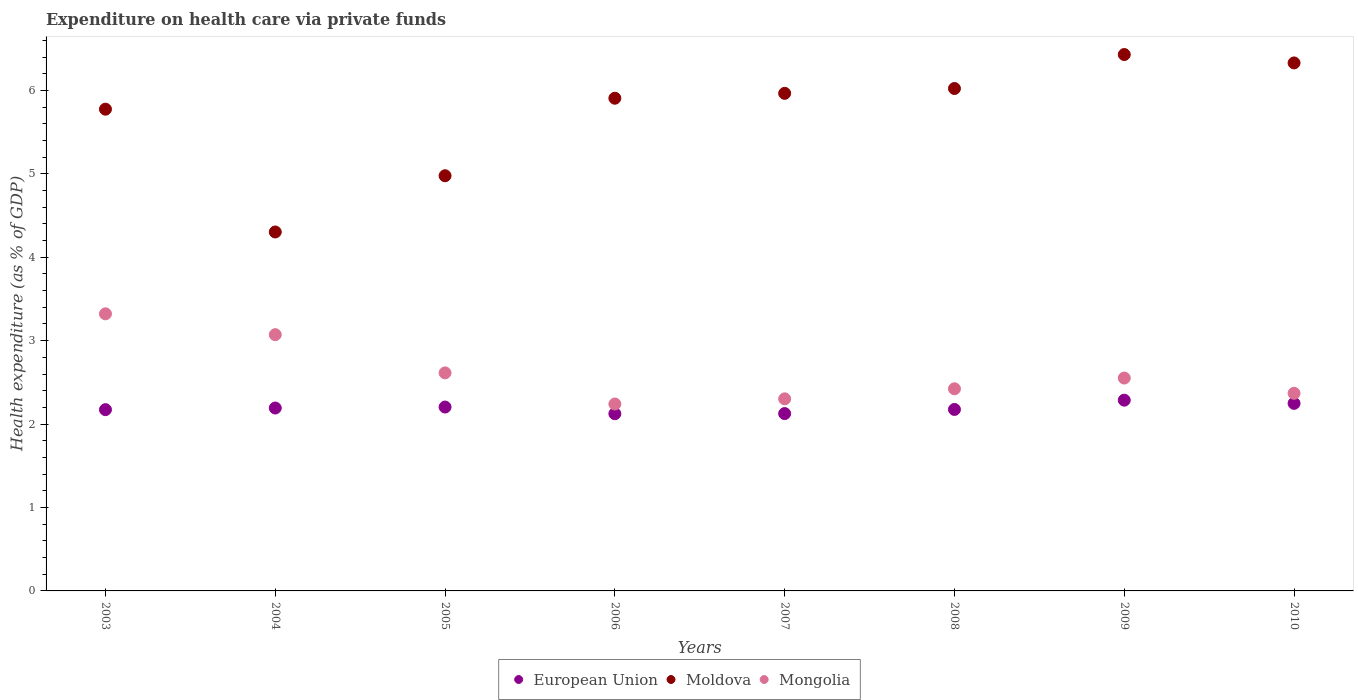What is the expenditure made on health care in Mongolia in 2004?
Offer a very short reply. 3.07. Across all years, what is the maximum expenditure made on health care in European Union?
Your answer should be very brief. 2.29. Across all years, what is the minimum expenditure made on health care in Moldova?
Your response must be concise. 4.3. In which year was the expenditure made on health care in Mongolia minimum?
Ensure brevity in your answer.  2006. What is the total expenditure made on health care in Mongolia in the graph?
Give a very brief answer. 20.9. What is the difference between the expenditure made on health care in Moldova in 2008 and that in 2009?
Keep it short and to the point. -0.41. What is the difference between the expenditure made on health care in Moldova in 2008 and the expenditure made on health care in Mongolia in 2007?
Your response must be concise. 3.72. What is the average expenditure made on health care in European Union per year?
Keep it short and to the point. 2.19. In the year 2007, what is the difference between the expenditure made on health care in Mongolia and expenditure made on health care in Moldova?
Offer a very short reply. -3.66. In how many years, is the expenditure made on health care in European Union greater than 4.6 %?
Provide a succinct answer. 0. What is the ratio of the expenditure made on health care in Mongolia in 2006 to that in 2010?
Give a very brief answer. 0.95. Is the expenditure made on health care in Mongolia in 2003 less than that in 2007?
Provide a succinct answer. No. Is the difference between the expenditure made on health care in Mongolia in 2005 and 2007 greater than the difference between the expenditure made on health care in Moldova in 2005 and 2007?
Your answer should be compact. Yes. What is the difference between the highest and the second highest expenditure made on health care in Moldova?
Give a very brief answer. 0.1. What is the difference between the highest and the lowest expenditure made on health care in European Union?
Offer a very short reply. 0.16. In how many years, is the expenditure made on health care in European Union greater than the average expenditure made on health care in European Union taken over all years?
Offer a very short reply. 4. Is the expenditure made on health care in Moldova strictly less than the expenditure made on health care in Mongolia over the years?
Your response must be concise. No. How many years are there in the graph?
Make the answer very short. 8. Are the values on the major ticks of Y-axis written in scientific E-notation?
Make the answer very short. No. What is the title of the graph?
Offer a terse response. Expenditure on health care via private funds. What is the label or title of the X-axis?
Your response must be concise. Years. What is the label or title of the Y-axis?
Your answer should be very brief. Health expenditure (as % of GDP). What is the Health expenditure (as % of GDP) of European Union in 2003?
Offer a very short reply. 2.17. What is the Health expenditure (as % of GDP) of Moldova in 2003?
Make the answer very short. 5.78. What is the Health expenditure (as % of GDP) in Mongolia in 2003?
Provide a succinct answer. 3.32. What is the Health expenditure (as % of GDP) in European Union in 2004?
Ensure brevity in your answer.  2.19. What is the Health expenditure (as % of GDP) in Moldova in 2004?
Make the answer very short. 4.3. What is the Health expenditure (as % of GDP) of Mongolia in 2004?
Make the answer very short. 3.07. What is the Health expenditure (as % of GDP) of European Union in 2005?
Keep it short and to the point. 2.2. What is the Health expenditure (as % of GDP) in Moldova in 2005?
Ensure brevity in your answer.  4.98. What is the Health expenditure (as % of GDP) of Mongolia in 2005?
Ensure brevity in your answer.  2.61. What is the Health expenditure (as % of GDP) in European Union in 2006?
Provide a short and direct response. 2.12. What is the Health expenditure (as % of GDP) of Moldova in 2006?
Your answer should be compact. 5.91. What is the Health expenditure (as % of GDP) of Mongolia in 2006?
Offer a very short reply. 2.24. What is the Health expenditure (as % of GDP) in European Union in 2007?
Make the answer very short. 2.13. What is the Health expenditure (as % of GDP) of Moldova in 2007?
Provide a short and direct response. 5.96. What is the Health expenditure (as % of GDP) of Mongolia in 2007?
Offer a terse response. 2.3. What is the Health expenditure (as % of GDP) of European Union in 2008?
Your answer should be very brief. 2.18. What is the Health expenditure (as % of GDP) in Moldova in 2008?
Keep it short and to the point. 6.02. What is the Health expenditure (as % of GDP) in Mongolia in 2008?
Ensure brevity in your answer.  2.42. What is the Health expenditure (as % of GDP) of European Union in 2009?
Keep it short and to the point. 2.29. What is the Health expenditure (as % of GDP) of Moldova in 2009?
Give a very brief answer. 6.43. What is the Health expenditure (as % of GDP) of Mongolia in 2009?
Your response must be concise. 2.55. What is the Health expenditure (as % of GDP) of European Union in 2010?
Offer a terse response. 2.25. What is the Health expenditure (as % of GDP) of Moldova in 2010?
Offer a very short reply. 6.33. What is the Health expenditure (as % of GDP) of Mongolia in 2010?
Offer a terse response. 2.37. Across all years, what is the maximum Health expenditure (as % of GDP) in European Union?
Provide a short and direct response. 2.29. Across all years, what is the maximum Health expenditure (as % of GDP) in Moldova?
Your answer should be very brief. 6.43. Across all years, what is the maximum Health expenditure (as % of GDP) in Mongolia?
Offer a very short reply. 3.32. Across all years, what is the minimum Health expenditure (as % of GDP) in European Union?
Offer a very short reply. 2.12. Across all years, what is the minimum Health expenditure (as % of GDP) in Moldova?
Provide a succinct answer. 4.3. Across all years, what is the minimum Health expenditure (as % of GDP) of Mongolia?
Your answer should be very brief. 2.24. What is the total Health expenditure (as % of GDP) of European Union in the graph?
Give a very brief answer. 17.53. What is the total Health expenditure (as % of GDP) of Moldova in the graph?
Your answer should be very brief. 45.71. What is the total Health expenditure (as % of GDP) of Mongolia in the graph?
Offer a terse response. 20.9. What is the difference between the Health expenditure (as % of GDP) in European Union in 2003 and that in 2004?
Offer a very short reply. -0.02. What is the difference between the Health expenditure (as % of GDP) of Moldova in 2003 and that in 2004?
Your answer should be compact. 1.47. What is the difference between the Health expenditure (as % of GDP) of Mongolia in 2003 and that in 2004?
Ensure brevity in your answer.  0.25. What is the difference between the Health expenditure (as % of GDP) in European Union in 2003 and that in 2005?
Make the answer very short. -0.03. What is the difference between the Health expenditure (as % of GDP) of Moldova in 2003 and that in 2005?
Offer a very short reply. 0.8. What is the difference between the Health expenditure (as % of GDP) of Mongolia in 2003 and that in 2005?
Provide a succinct answer. 0.71. What is the difference between the Health expenditure (as % of GDP) of European Union in 2003 and that in 2006?
Offer a terse response. 0.05. What is the difference between the Health expenditure (as % of GDP) of Moldova in 2003 and that in 2006?
Provide a short and direct response. -0.13. What is the difference between the Health expenditure (as % of GDP) of Mongolia in 2003 and that in 2006?
Provide a succinct answer. 1.08. What is the difference between the Health expenditure (as % of GDP) in European Union in 2003 and that in 2007?
Your answer should be very brief. 0.05. What is the difference between the Health expenditure (as % of GDP) of Moldova in 2003 and that in 2007?
Offer a very short reply. -0.19. What is the difference between the Health expenditure (as % of GDP) in Mongolia in 2003 and that in 2007?
Your answer should be very brief. 1.02. What is the difference between the Health expenditure (as % of GDP) in European Union in 2003 and that in 2008?
Keep it short and to the point. -0. What is the difference between the Health expenditure (as % of GDP) in Moldova in 2003 and that in 2008?
Keep it short and to the point. -0.25. What is the difference between the Health expenditure (as % of GDP) in Mongolia in 2003 and that in 2008?
Keep it short and to the point. 0.9. What is the difference between the Health expenditure (as % of GDP) of European Union in 2003 and that in 2009?
Make the answer very short. -0.11. What is the difference between the Health expenditure (as % of GDP) in Moldova in 2003 and that in 2009?
Your answer should be very brief. -0.66. What is the difference between the Health expenditure (as % of GDP) in Mongolia in 2003 and that in 2009?
Your answer should be compact. 0.77. What is the difference between the Health expenditure (as % of GDP) in European Union in 2003 and that in 2010?
Offer a terse response. -0.08. What is the difference between the Health expenditure (as % of GDP) of Moldova in 2003 and that in 2010?
Your response must be concise. -0.55. What is the difference between the Health expenditure (as % of GDP) in Mongolia in 2003 and that in 2010?
Make the answer very short. 0.95. What is the difference between the Health expenditure (as % of GDP) in European Union in 2004 and that in 2005?
Your answer should be compact. -0.01. What is the difference between the Health expenditure (as % of GDP) in Moldova in 2004 and that in 2005?
Your answer should be very brief. -0.67. What is the difference between the Health expenditure (as % of GDP) of Mongolia in 2004 and that in 2005?
Give a very brief answer. 0.46. What is the difference between the Health expenditure (as % of GDP) in European Union in 2004 and that in 2006?
Give a very brief answer. 0.07. What is the difference between the Health expenditure (as % of GDP) in Moldova in 2004 and that in 2006?
Give a very brief answer. -1.6. What is the difference between the Health expenditure (as % of GDP) of Mongolia in 2004 and that in 2006?
Your answer should be very brief. 0.83. What is the difference between the Health expenditure (as % of GDP) in European Union in 2004 and that in 2007?
Provide a succinct answer. 0.07. What is the difference between the Health expenditure (as % of GDP) of Moldova in 2004 and that in 2007?
Keep it short and to the point. -1.66. What is the difference between the Health expenditure (as % of GDP) in Mongolia in 2004 and that in 2007?
Keep it short and to the point. 0.77. What is the difference between the Health expenditure (as % of GDP) of European Union in 2004 and that in 2008?
Give a very brief answer. 0.02. What is the difference between the Health expenditure (as % of GDP) of Moldova in 2004 and that in 2008?
Offer a terse response. -1.72. What is the difference between the Health expenditure (as % of GDP) of Mongolia in 2004 and that in 2008?
Ensure brevity in your answer.  0.65. What is the difference between the Health expenditure (as % of GDP) in European Union in 2004 and that in 2009?
Provide a succinct answer. -0.09. What is the difference between the Health expenditure (as % of GDP) of Moldova in 2004 and that in 2009?
Your answer should be compact. -2.13. What is the difference between the Health expenditure (as % of GDP) in Mongolia in 2004 and that in 2009?
Your response must be concise. 0.52. What is the difference between the Health expenditure (as % of GDP) of European Union in 2004 and that in 2010?
Provide a succinct answer. -0.06. What is the difference between the Health expenditure (as % of GDP) of Moldova in 2004 and that in 2010?
Ensure brevity in your answer.  -2.03. What is the difference between the Health expenditure (as % of GDP) of Mongolia in 2004 and that in 2010?
Your answer should be compact. 0.7. What is the difference between the Health expenditure (as % of GDP) in European Union in 2005 and that in 2006?
Your response must be concise. 0.08. What is the difference between the Health expenditure (as % of GDP) in Moldova in 2005 and that in 2006?
Offer a terse response. -0.93. What is the difference between the Health expenditure (as % of GDP) of Mongolia in 2005 and that in 2006?
Give a very brief answer. 0.37. What is the difference between the Health expenditure (as % of GDP) in European Union in 2005 and that in 2007?
Offer a terse response. 0.08. What is the difference between the Health expenditure (as % of GDP) in Moldova in 2005 and that in 2007?
Your answer should be very brief. -0.99. What is the difference between the Health expenditure (as % of GDP) in Mongolia in 2005 and that in 2007?
Your response must be concise. 0.31. What is the difference between the Health expenditure (as % of GDP) of European Union in 2005 and that in 2008?
Offer a terse response. 0.03. What is the difference between the Health expenditure (as % of GDP) of Moldova in 2005 and that in 2008?
Provide a succinct answer. -1.05. What is the difference between the Health expenditure (as % of GDP) of Mongolia in 2005 and that in 2008?
Offer a terse response. 0.19. What is the difference between the Health expenditure (as % of GDP) of European Union in 2005 and that in 2009?
Ensure brevity in your answer.  -0.08. What is the difference between the Health expenditure (as % of GDP) of Moldova in 2005 and that in 2009?
Keep it short and to the point. -1.45. What is the difference between the Health expenditure (as % of GDP) of Mongolia in 2005 and that in 2009?
Make the answer very short. 0.06. What is the difference between the Health expenditure (as % of GDP) of European Union in 2005 and that in 2010?
Provide a short and direct response. -0.04. What is the difference between the Health expenditure (as % of GDP) of Moldova in 2005 and that in 2010?
Offer a very short reply. -1.35. What is the difference between the Health expenditure (as % of GDP) of Mongolia in 2005 and that in 2010?
Provide a succinct answer. 0.24. What is the difference between the Health expenditure (as % of GDP) of European Union in 2006 and that in 2007?
Offer a terse response. -0. What is the difference between the Health expenditure (as % of GDP) in Moldova in 2006 and that in 2007?
Keep it short and to the point. -0.06. What is the difference between the Health expenditure (as % of GDP) in Mongolia in 2006 and that in 2007?
Your answer should be very brief. -0.06. What is the difference between the Health expenditure (as % of GDP) in European Union in 2006 and that in 2008?
Your response must be concise. -0.05. What is the difference between the Health expenditure (as % of GDP) of Moldova in 2006 and that in 2008?
Provide a short and direct response. -0.12. What is the difference between the Health expenditure (as % of GDP) in Mongolia in 2006 and that in 2008?
Make the answer very short. -0.18. What is the difference between the Health expenditure (as % of GDP) of European Union in 2006 and that in 2009?
Offer a terse response. -0.16. What is the difference between the Health expenditure (as % of GDP) of Moldova in 2006 and that in 2009?
Make the answer very short. -0.52. What is the difference between the Health expenditure (as % of GDP) in Mongolia in 2006 and that in 2009?
Your response must be concise. -0.31. What is the difference between the Health expenditure (as % of GDP) of European Union in 2006 and that in 2010?
Provide a short and direct response. -0.12. What is the difference between the Health expenditure (as % of GDP) of Moldova in 2006 and that in 2010?
Ensure brevity in your answer.  -0.42. What is the difference between the Health expenditure (as % of GDP) of Mongolia in 2006 and that in 2010?
Provide a short and direct response. -0.13. What is the difference between the Health expenditure (as % of GDP) in European Union in 2007 and that in 2008?
Your response must be concise. -0.05. What is the difference between the Health expenditure (as % of GDP) in Moldova in 2007 and that in 2008?
Offer a very short reply. -0.06. What is the difference between the Health expenditure (as % of GDP) of Mongolia in 2007 and that in 2008?
Your answer should be compact. -0.12. What is the difference between the Health expenditure (as % of GDP) in European Union in 2007 and that in 2009?
Offer a terse response. -0.16. What is the difference between the Health expenditure (as % of GDP) in Moldova in 2007 and that in 2009?
Your answer should be very brief. -0.47. What is the difference between the Health expenditure (as % of GDP) of Mongolia in 2007 and that in 2009?
Your response must be concise. -0.25. What is the difference between the Health expenditure (as % of GDP) of European Union in 2007 and that in 2010?
Your answer should be compact. -0.12. What is the difference between the Health expenditure (as % of GDP) in Moldova in 2007 and that in 2010?
Your response must be concise. -0.36. What is the difference between the Health expenditure (as % of GDP) of Mongolia in 2007 and that in 2010?
Ensure brevity in your answer.  -0.07. What is the difference between the Health expenditure (as % of GDP) of European Union in 2008 and that in 2009?
Offer a very short reply. -0.11. What is the difference between the Health expenditure (as % of GDP) in Moldova in 2008 and that in 2009?
Your answer should be very brief. -0.41. What is the difference between the Health expenditure (as % of GDP) in Mongolia in 2008 and that in 2009?
Your answer should be very brief. -0.13. What is the difference between the Health expenditure (as % of GDP) in European Union in 2008 and that in 2010?
Keep it short and to the point. -0.07. What is the difference between the Health expenditure (as % of GDP) of Moldova in 2008 and that in 2010?
Offer a terse response. -0.31. What is the difference between the Health expenditure (as % of GDP) in Mongolia in 2008 and that in 2010?
Provide a succinct answer. 0.05. What is the difference between the Health expenditure (as % of GDP) in European Union in 2009 and that in 2010?
Make the answer very short. 0.04. What is the difference between the Health expenditure (as % of GDP) in Moldova in 2009 and that in 2010?
Your response must be concise. 0.1. What is the difference between the Health expenditure (as % of GDP) of Mongolia in 2009 and that in 2010?
Provide a succinct answer. 0.18. What is the difference between the Health expenditure (as % of GDP) in European Union in 2003 and the Health expenditure (as % of GDP) in Moldova in 2004?
Your response must be concise. -2.13. What is the difference between the Health expenditure (as % of GDP) of European Union in 2003 and the Health expenditure (as % of GDP) of Mongolia in 2004?
Your answer should be very brief. -0.9. What is the difference between the Health expenditure (as % of GDP) in Moldova in 2003 and the Health expenditure (as % of GDP) in Mongolia in 2004?
Offer a terse response. 2.7. What is the difference between the Health expenditure (as % of GDP) of European Union in 2003 and the Health expenditure (as % of GDP) of Moldova in 2005?
Ensure brevity in your answer.  -2.8. What is the difference between the Health expenditure (as % of GDP) in European Union in 2003 and the Health expenditure (as % of GDP) in Mongolia in 2005?
Ensure brevity in your answer.  -0.44. What is the difference between the Health expenditure (as % of GDP) in Moldova in 2003 and the Health expenditure (as % of GDP) in Mongolia in 2005?
Offer a very short reply. 3.16. What is the difference between the Health expenditure (as % of GDP) of European Union in 2003 and the Health expenditure (as % of GDP) of Moldova in 2006?
Make the answer very short. -3.73. What is the difference between the Health expenditure (as % of GDP) of European Union in 2003 and the Health expenditure (as % of GDP) of Mongolia in 2006?
Provide a short and direct response. -0.07. What is the difference between the Health expenditure (as % of GDP) in Moldova in 2003 and the Health expenditure (as % of GDP) in Mongolia in 2006?
Ensure brevity in your answer.  3.53. What is the difference between the Health expenditure (as % of GDP) in European Union in 2003 and the Health expenditure (as % of GDP) in Moldova in 2007?
Make the answer very short. -3.79. What is the difference between the Health expenditure (as % of GDP) of European Union in 2003 and the Health expenditure (as % of GDP) of Mongolia in 2007?
Ensure brevity in your answer.  -0.13. What is the difference between the Health expenditure (as % of GDP) of Moldova in 2003 and the Health expenditure (as % of GDP) of Mongolia in 2007?
Provide a succinct answer. 3.47. What is the difference between the Health expenditure (as % of GDP) in European Union in 2003 and the Health expenditure (as % of GDP) in Moldova in 2008?
Your answer should be compact. -3.85. What is the difference between the Health expenditure (as % of GDP) in European Union in 2003 and the Health expenditure (as % of GDP) in Mongolia in 2008?
Your answer should be very brief. -0.25. What is the difference between the Health expenditure (as % of GDP) in Moldova in 2003 and the Health expenditure (as % of GDP) in Mongolia in 2008?
Your response must be concise. 3.35. What is the difference between the Health expenditure (as % of GDP) in European Union in 2003 and the Health expenditure (as % of GDP) in Moldova in 2009?
Keep it short and to the point. -4.26. What is the difference between the Health expenditure (as % of GDP) of European Union in 2003 and the Health expenditure (as % of GDP) of Mongolia in 2009?
Make the answer very short. -0.38. What is the difference between the Health expenditure (as % of GDP) in Moldova in 2003 and the Health expenditure (as % of GDP) in Mongolia in 2009?
Offer a very short reply. 3.22. What is the difference between the Health expenditure (as % of GDP) in European Union in 2003 and the Health expenditure (as % of GDP) in Moldova in 2010?
Offer a terse response. -4.16. What is the difference between the Health expenditure (as % of GDP) in European Union in 2003 and the Health expenditure (as % of GDP) in Mongolia in 2010?
Keep it short and to the point. -0.2. What is the difference between the Health expenditure (as % of GDP) in Moldova in 2003 and the Health expenditure (as % of GDP) in Mongolia in 2010?
Make the answer very short. 3.41. What is the difference between the Health expenditure (as % of GDP) in European Union in 2004 and the Health expenditure (as % of GDP) in Moldova in 2005?
Your answer should be very brief. -2.78. What is the difference between the Health expenditure (as % of GDP) in European Union in 2004 and the Health expenditure (as % of GDP) in Mongolia in 2005?
Your response must be concise. -0.42. What is the difference between the Health expenditure (as % of GDP) in Moldova in 2004 and the Health expenditure (as % of GDP) in Mongolia in 2005?
Offer a very short reply. 1.69. What is the difference between the Health expenditure (as % of GDP) in European Union in 2004 and the Health expenditure (as % of GDP) in Moldova in 2006?
Offer a very short reply. -3.71. What is the difference between the Health expenditure (as % of GDP) of European Union in 2004 and the Health expenditure (as % of GDP) of Mongolia in 2006?
Keep it short and to the point. -0.05. What is the difference between the Health expenditure (as % of GDP) in Moldova in 2004 and the Health expenditure (as % of GDP) in Mongolia in 2006?
Your answer should be very brief. 2.06. What is the difference between the Health expenditure (as % of GDP) in European Union in 2004 and the Health expenditure (as % of GDP) in Moldova in 2007?
Provide a short and direct response. -3.77. What is the difference between the Health expenditure (as % of GDP) in European Union in 2004 and the Health expenditure (as % of GDP) in Mongolia in 2007?
Offer a terse response. -0.11. What is the difference between the Health expenditure (as % of GDP) of Moldova in 2004 and the Health expenditure (as % of GDP) of Mongolia in 2007?
Keep it short and to the point. 2. What is the difference between the Health expenditure (as % of GDP) of European Union in 2004 and the Health expenditure (as % of GDP) of Moldova in 2008?
Your response must be concise. -3.83. What is the difference between the Health expenditure (as % of GDP) of European Union in 2004 and the Health expenditure (as % of GDP) of Mongolia in 2008?
Offer a terse response. -0.23. What is the difference between the Health expenditure (as % of GDP) in Moldova in 2004 and the Health expenditure (as % of GDP) in Mongolia in 2008?
Your answer should be very brief. 1.88. What is the difference between the Health expenditure (as % of GDP) of European Union in 2004 and the Health expenditure (as % of GDP) of Moldova in 2009?
Ensure brevity in your answer.  -4.24. What is the difference between the Health expenditure (as % of GDP) in European Union in 2004 and the Health expenditure (as % of GDP) in Mongolia in 2009?
Provide a short and direct response. -0.36. What is the difference between the Health expenditure (as % of GDP) of Moldova in 2004 and the Health expenditure (as % of GDP) of Mongolia in 2009?
Offer a terse response. 1.75. What is the difference between the Health expenditure (as % of GDP) of European Union in 2004 and the Health expenditure (as % of GDP) of Moldova in 2010?
Keep it short and to the point. -4.14. What is the difference between the Health expenditure (as % of GDP) of European Union in 2004 and the Health expenditure (as % of GDP) of Mongolia in 2010?
Provide a short and direct response. -0.18. What is the difference between the Health expenditure (as % of GDP) of Moldova in 2004 and the Health expenditure (as % of GDP) of Mongolia in 2010?
Offer a very short reply. 1.93. What is the difference between the Health expenditure (as % of GDP) in European Union in 2005 and the Health expenditure (as % of GDP) in Moldova in 2006?
Offer a very short reply. -3.7. What is the difference between the Health expenditure (as % of GDP) in European Union in 2005 and the Health expenditure (as % of GDP) in Mongolia in 2006?
Provide a short and direct response. -0.04. What is the difference between the Health expenditure (as % of GDP) of Moldova in 2005 and the Health expenditure (as % of GDP) of Mongolia in 2006?
Your response must be concise. 2.74. What is the difference between the Health expenditure (as % of GDP) of European Union in 2005 and the Health expenditure (as % of GDP) of Moldova in 2007?
Make the answer very short. -3.76. What is the difference between the Health expenditure (as % of GDP) in European Union in 2005 and the Health expenditure (as % of GDP) in Mongolia in 2007?
Your answer should be very brief. -0.1. What is the difference between the Health expenditure (as % of GDP) in Moldova in 2005 and the Health expenditure (as % of GDP) in Mongolia in 2007?
Provide a succinct answer. 2.67. What is the difference between the Health expenditure (as % of GDP) of European Union in 2005 and the Health expenditure (as % of GDP) of Moldova in 2008?
Keep it short and to the point. -3.82. What is the difference between the Health expenditure (as % of GDP) in European Union in 2005 and the Health expenditure (as % of GDP) in Mongolia in 2008?
Provide a succinct answer. -0.22. What is the difference between the Health expenditure (as % of GDP) of Moldova in 2005 and the Health expenditure (as % of GDP) of Mongolia in 2008?
Give a very brief answer. 2.55. What is the difference between the Health expenditure (as % of GDP) in European Union in 2005 and the Health expenditure (as % of GDP) in Moldova in 2009?
Provide a succinct answer. -4.23. What is the difference between the Health expenditure (as % of GDP) of European Union in 2005 and the Health expenditure (as % of GDP) of Mongolia in 2009?
Offer a very short reply. -0.35. What is the difference between the Health expenditure (as % of GDP) of Moldova in 2005 and the Health expenditure (as % of GDP) of Mongolia in 2009?
Keep it short and to the point. 2.43. What is the difference between the Health expenditure (as % of GDP) of European Union in 2005 and the Health expenditure (as % of GDP) of Moldova in 2010?
Provide a succinct answer. -4.13. What is the difference between the Health expenditure (as % of GDP) in European Union in 2005 and the Health expenditure (as % of GDP) in Mongolia in 2010?
Give a very brief answer. -0.16. What is the difference between the Health expenditure (as % of GDP) of Moldova in 2005 and the Health expenditure (as % of GDP) of Mongolia in 2010?
Provide a succinct answer. 2.61. What is the difference between the Health expenditure (as % of GDP) in European Union in 2006 and the Health expenditure (as % of GDP) in Moldova in 2007?
Keep it short and to the point. -3.84. What is the difference between the Health expenditure (as % of GDP) in European Union in 2006 and the Health expenditure (as % of GDP) in Mongolia in 2007?
Your answer should be very brief. -0.18. What is the difference between the Health expenditure (as % of GDP) of Moldova in 2006 and the Health expenditure (as % of GDP) of Mongolia in 2007?
Make the answer very short. 3.6. What is the difference between the Health expenditure (as % of GDP) of European Union in 2006 and the Health expenditure (as % of GDP) of Moldova in 2008?
Your answer should be very brief. -3.9. What is the difference between the Health expenditure (as % of GDP) of European Union in 2006 and the Health expenditure (as % of GDP) of Mongolia in 2008?
Your response must be concise. -0.3. What is the difference between the Health expenditure (as % of GDP) of Moldova in 2006 and the Health expenditure (as % of GDP) of Mongolia in 2008?
Keep it short and to the point. 3.48. What is the difference between the Health expenditure (as % of GDP) of European Union in 2006 and the Health expenditure (as % of GDP) of Moldova in 2009?
Your response must be concise. -4.31. What is the difference between the Health expenditure (as % of GDP) of European Union in 2006 and the Health expenditure (as % of GDP) of Mongolia in 2009?
Provide a short and direct response. -0.43. What is the difference between the Health expenditure (as % of GDP) in Moldova in 2006 and the Health expenditure (as % of GDP) in Mongolia in 2009?
Keep it short and to the point. 3.35. What is the difference between the Health expenditure (as % of GDP) in European Union in 2006 and the Health expenditure (as % of GDP) in Moldova in 2010?
Offer a very short reply. -4.21. What is the difference between the Health expenditure (as % of GDP) in European Union in 2006 and the Health expenditure (as % of GDP) in Mongolia in 2010?
Your answer should be compact. -0.24. What is the difference between the Health expenditure (as % of GDP) in Moldova in 2006 and the Health expenditure (as % of GDP) in Mongolia in 2010?
Your answer should be compact. 3.54. What is the difference between the Health expenditure (as % of GDP) in European Union in 2007 and the Health expenditure (as % of GDP) in Moldova in 2008?
Your response must be concise. -3.9. What is the difference between the Health expenditure (as % of GDP) of European Union in 2007 and the Health expenditure (as % of GDP) of Mongolia in 2008?
Provide a succinct answer. -0.3. What is the difference between the Health expenditure (as % of GDP) in Moldova in 2007 and the Health expenditure (as % of GDP) in Mongolia in 2008?
Offer a terse response. 3.54. What is the difference between the Health expenditure (as % of GDP) in European Union in 2007 and the Health expenditure (as % of GDP) in Moldova in 2009?
Your answer should be very brief. -4.3. What is the difference between the Health expenditure (as % of GDP) in European Union in 2007 and the Health expenditure (as % of GDP) in Mongolia in 2009?
Give a very brief answer. -0.43. What is the difference between the Health expenditure (as % of GDP) of Moldova in 2007 and the Health expenditure (as % of GDP) of Mongolia in 2009?
Make the answer very short. 3.41. What is the difference between the Health expenditure (as % of GDP) in European Union in 2007 and the Health expenditure (as % of GDP) in Moldova in 2010?
Your answer should be very brief. -4.2. What is the difference between the Health expenditure (as % of GDP) of European Union in 2007 and the Health expenditure (as % of GDP) of Mongolia in 2010?
Make the answer very short. -0.24. What is the difference between the Health expenditure (as % of GDP) of Moldova in 2007 and the Health expenditure (as % of GDP) of Mongolia in 2010?
Keep it short and to the point. 3.6. What is the difference between the Health expenditure (as % of GDP) in European Union in 2008 and the Health expenditure (as % of GDP) in Moldova in 2009?
Your answer should be very brief. -4.25. What is the difference between the Health expenditure (as % of GDP) of European Union in 2008 and the Health expenditure (as % of GDP) of Mongolia in 2009?
Make the answer very short. -0.38. What is the difference between the Health expenditure (as % of GDP) in Moldova in 2008 and the Health expenditure (as % of GDP) in Mongolia in 2009?
Your answer should be compact. 3.47. What is the difference between the Health expenditure (as % of GDP) of European Union in 2008 and the Health expenditure (as % of GDP) of Moldova in 2010?
Ensure brevity in your answer.  -4.15. What is the difference between the Health expenditure (as % of GDP) in European Union in 2008 and the Health expenditure (as % of GDP) in Mongolia in 2010?
Make the answer very short. -0.19. What is the difference between the Health expenditure (as % of GDP) of Moldova in 2008 and the Health expenditure (as % of GDP) of Mongolia in 2010?
Your answer should be compact. 3.65. What is the difference between the Health expenditure (as % of GDP) in European Union in 2009 and the Health expenditure (as % of GDP) in Moldova in 2010?
Ensure brevity in your answer.  -4.04. What is the difference between the Health expenditure (as % of GDP) of European Union in 2009 and the Health expenditure (as % of GDP) of Mongolia in 2010?
Make the answer very short. -0.08. What is the difference between the Health expenditure (as % of GDP) of Moldova in 2009 and the Health expenditure (as % of GDP) of Mongolia in 2010?
Your answer should be compact. 4.06. What is the average Health expenditure (as % of GDP) in European Union per year?
Provide a succinct answer. 2.19. What is the average Health expenditure (as % of GDP) of Moldova per year?
Ensure brevity in your answer.  5.71. What is the average Health expenditure (as % of GDP) in Mongolia per year?
Give a very brief answer. 2.61. In the year 2003, what is the difference between the Health expenditure (as % of GDP) in European Union and Health expenditure (as % of GDP) in Moldova?
Ensure brevity in your answer.  -3.6. In the year 2003, what is the difference between the Health expenditure (as % of GDP) of European Union and Health expenditure (as % of GDP) of Mongolia?
Ensure brevity in your answer.  -1.15. In the year 2003, what is the difference between the Health expenditure (as % of GDP) of Moldova and Health expenditure (as % of GDP) of Mongolia?
Your answer should be very brief. 2.45. In the year 2004, what is the difference between the Health expenditure (as % of GDP) in European Union and Health expenditure (as % of GDP) in Moldova?
Give a very brief answer. -2.11. In the year 2004, what is the difference between the Health expenditure (as % of GDP) in European Union and Health expenditure (as % of GDP) in Mongolia?
Your response must be concise. -0.88. In the year 2004, what is the difference between the Health expenditure (as % of GDP) in Moldova and Health expenditure (as % of GDP) in Mongolia?
Offer a terse response. 1.23. In the year 2005, what is the difference between the Health expenditure (as % of GDP) of European Union and Health expenditure (as % of GDP) of Moldova?
Your response must be concise. -2.77. In the year 2005, what is the difference between the Health expenditure (as % of GDP) in European Union and Health expenditure (as % of GDP) in Mongolia?
Offer a terse response. -0.41. In the year 2005, what is the difference between the Health expenditure (as % of GDP) in Moldova and Health expenditure (as % of GDP) in Mongolia?
Provide a short and direct response. 2.36. In the year 2006, what is the difference between the Health expenditure (as % of GDP) in European Union and Health expenditure (as % of GDP) in Moldova?
Your response must be concise. -3.78. In the year 2006, what is the difference between the Health expenditure (as % of GDP) in European Union and Health expenditure (as % of GDP) in Mongolia?
Offer a terse response. -0.12. In the year 2006, what is the difference between the Health expenditure (as % of GDP) in Moldova and Health expenditure (as % of GDP) in Mongolia?
Provide a short and direct response. 3.67. In the year 2007, what is the difference between the Health expenditure (as % of GDP) in European Union and Health expenditure (as % of GDP) in Moldova?
Provide a short and direct response. -3.84. In the year 2007, what is the difference between the Health expenditure (as % of GDP) in European Union and Health expenditure (as % of GDP) in Mongolia?
Your response must be concise. -0.18. In the year 2007, what is the difference between the Health expenditure (as % of GDP) in Moldova and Health expenditure (as % of GDP) in Mongolia?
Your answer should be very brief. 3.66. In the year 2008, what is the difference between the Health expenditure (as % of GDP) of European Union and Health expenditure (as % of GDP) of Moldova?
Give a very brief answer. -3.85. In the year 2008, what is the difference between the Health expenditure (as % of GDP) in European Union and Health expenditure (as % of GDP) in Mongolia?
Provide a succinct answer. -0.25. In the year 2008, what is the difference between the Health expenditure (as % of GDP) in Moldova and Health expenditure (as % of GDP) in Mongolia?
Offer a very short reply. 3.6. In the year 2009, what is the difference between the Health expenditure (as % of GDP) of European Union and Health expenditure (as % of GDP) of Moldova?
Provide a succinct answer. -4.14. In the year 2009, what is the difference between the Health expenditure (as % of GDP) in European Union and Health expenditure (as % of GDP) in Mongolia?
Ensure brevity in your answer.  -0.27. In the year 2009, what is the difference between the Health expenditure (as % of GDP) of Moldova and Health expenditure (as % of GDP) of Mongolia?
Give a very brief answer. 3.88. In the year 2010, what is the difference between the Health expenditure (as % of GDP) in European Union and Health expenditure (as % of GDP) in Moldova?
Ensure brevity in your answer.  -4.08. In the year 2010, what is the difference between the Health expenditure (as % of GDP) of European Union and Health expenditure (as % of GDP) of Mongolia?
Give a very brief answer. -0.12. In the year 2010, what is the difference between the Health expenditure (as % of GDP) of Moldova and Health expenditure (as % of GDP) of Mongolia?
Your answer should be compact. 3.96. What is the ratio of the Health expenditure (as % of GDP) of European Union in 2003 to that in 2004?
Ensure brevity in your answer.  0.99. What is the ratio of the Health expenditure (as % of GDP) in Moldova in 2003 to that in 2004?
Ensure brevity in your answer.  1.34. What is the ratio of the Health expenditure (as % of GDP) in Mongolia in 2003 to that in 2004?
Your answer should be very brief. 1.08. What is the ratio of the Health expenditure (as % of GDP) of European Union in 2003 to that in 2005?
Your response must be concise. 0.99. What is the ratio of the Health expenditure (as % of GDP) of Moldova in 2003 to that in 2005?
Your answer should be compact. 1.16. What is the ratio of the Health expenditure (as % of GDP) of Mongolia in 2003 to that in 2005?
Provide a succinct answer. 1.27. What is the ratio of the Health expenditure (as % of GDP) of European Union in 2003 to that in 2006?
Offer a terse response. 1.02. What is the ratio of the Health expenditure (as % of GDP) in Moldova in 2003 to that in 2006?
Make the answer very short. 0.98. What is the ratio of the Health expenditure (as % of GDP) of Mongolia in 2003 to that in 2006?
Give a very brief answer. 1.48. What is the ratio of the Health expenditure (as % of GDP) of European Union in 2003 to that in 2007?
Your answer should be compact. 1.02. What is the ratio of the Health expenditure (as % of GDP) in Moldova in 2003 to that in 2007?
Your answer should be compact. 0.97. What is the ratio of the Health expenditure (as % of GDP) in Mongolia in 2003 to that in 2007?
Provide a succinct answer. 1.44. What is the ratio of the Health expenditure (as % of GDP) of European Union in 2003 to that in 2008?
Provide a succinct answer. 1. What is the ratio of the Health expenditure (as % of GDP) of Moldova in 2003 to that in 2008?
Offer a terse response. 0.96. What is the ratio of the Health expenditure (as % of GDP) in Mongolia in 2003 to that in 2008?
Give a very brief answer. 1.37. What is the ratio of the Health expenditure (as % of GDP) of European Union in 2003 to that in 2009?
Your answer should be compact. 0.95. What is the ratio of the Health expenditure (as % of GDP) in Moldova in 2003 to that in 2009?
Your answer should be compact. 0.9. What is the ratio of the Health expenditure (as % of GDP) in Mongolia in 2003 to that in 2009?
Give a very brief answer. 1.3. What is the ratio of the Health expenditure (as % of GDP) in European Union in 2003 to that in 2010?
Keep it short and to the point. 0.97. What is the ratio of the Health expenditure (as % of GDP) in Moldova in 2003 to that in 2010?
Give a very brief answer. 0.91. What is the ratio of the Health expenditure (as % of GDP) of Mongolia in 2003 to that in 2010?
Provide a succinct answer. 1.4. What is the ratio of the Health expenditure (as % of GDP) of European Union in 2004 to that in 2005?
Provide a succinct answer. 0.99. What is the ratio of the Health expenditure (as % of GDP) of Moldova in 2004 to that in 2005?
Offer a terse response. 0.86. What is the ratio of the Health expenditure (as % of GDP) of Mongolia in 2004 to that in 2005?
Provide a short and direct response. 1.18. What is the ratio of the Health expenditure (as % of GDP) in European Union in 2004 to that in 2006?
Your answer should be very brief. 1.03. What is the ratio of the Health expenditure (as % of GDP) of Moldova in 2004 to that in 2006?
Provide a succinct answer. 0.73. What is the ratio of the Health expenditure (as % of GDP) in Mongolia in 2004 to that in 2006?
Provide a short and direct response. 1.37. What is the ratio of the Health expenditure (as % of GDP) in European Union in 2004 to that in 2007?
Keep it short and to the point. 1.03. What is the ratio of the Health expenditure (as % of GDP) of Moldova in 2004 to that in 2007?
Ensure brevity in your answer.  0.72. What is the ratio of the Health expenditure (as % of GDP) of Mongolia in 2004 to that in 2007?
Provide a short and direct response. 1.33. What is the ratio of the Health expenditure (as % of GDP) in Moldova in 2004 to that in 2008?
Your answer should be very brief. 0.71. What is the ratio of the Health expenditure (as % of GDP) of Mongolia in 2004 to that in 2008?
Offer a terse response. 1.27. What is the ratio of the Health expenditure (as % of GDP) of European Union in 2004 to that in 2009?
Provide a short and direct response. 0.96. What is the ratio of the Health expenditure (as % of GDP) of Moldova in 2004 to that in 2009?
Your answer should be very brief. 0.67. What is the ratio of the Health expenditure (as % of GDP) in Mongolia in 2004 to that in 2009?
Your response must be concise. 1.2. What is the ratio of the Health expenditure (as % of GDP) in European Union in 2004 to that in 2010?
Provide a short and direct response. 0.98. What is the ratio of the Health expenditure (as % of GDP) of Moldova in 2004 to that in 2010?
Your answer should be very brief. 0.68. What is the ratio of the Health expenditure (as % of GDP) in Mongolia in 2004 to that in 2010?
Provide a short and direct response. 1.3. What is the ratio of the Health expenditure (as % of GDP) in European Union in 2005 to that in 2006?
Make the answer very short. 1.04. What is the ratio of the Health expenditure (as % of GDP) in Moldova in 2005 to that in 2006?
Your answer should be compact. 0.84. What is the ratio of the Health expenditure (as % of GDP) of Mongolia in 2005 to that in 2006?
Keep it short and to the point. 1.17. What is the ratio of the Health expenditure (as % of GDP) in European Union in 2005 to that in 2007?
Offer a very short reply. 1.04. What is the ratio of the Health expenditure (as % of GDP) in Moldova in 2005 to that in 2007?
Ensure brevity in your answer.  0.83. What is the ratio of the Health expenditure (as % of GDP) of Mongolia in 2005 to that in 2007?
Your answer should be compact. 1.14. What is the ratio of the Health expenditure (as % of GDP) in European Union in 2005 to that in 2008?
Your answer should be very brief. 1.01. What is the ratio of the Health expenditure (as % of GDP) of Moldova in 2005 to that in 2008?
Keep it short and to the point. 0.83. What is the ratio of the Health expenditure (as % of GDP) in Mongolia in 2005 to that in 2008?
Give a very brief answer. 1.08. What is the ratio of the Health expenditure (as % of GDP) in Moldova in 2005 to that in 2009?
Your answer should be very brief. 0.77. What is the ratio of the Health expenditure (as % of GDP) in Mongolia in 2005 to that in 2009?
Your answer should be very brief. 1.02. What is the ratio of the Health expenditure (as % of GDP) in European Union in 2005 to that in 2010?
Give a very brief answer. 0.98. What is the ratio of the Health expenditure (as % of GDP) in Moldova in 2005 to that in 2010?
Offer a very short reply. 0.79. What is the ratio of the Health expenditure (as % of GDP) of Mongolia in 2005 to that in 2010?
Provide a short and direct response. 1.1. What is the ratio of the Health expenditure (as % of GDP) in Moldova in 2006 to that in 2007?
Your answer should be compact. 0.99. What is the ratio of the Health expenditure (as % of GDP) in Mongolia in 2006 to that in 2007?
Provide a short and direct response. 0.97. What is the ratio of the Health expenditure (as % of GDP) in European Union in 2006 to that in 2008?
Offer a very short reply. 0.98. What is the ratio of the Health expenditure (as % of GDP) of Moldova in 2006 to that in 2008?
Give a very brief answer. 0.98. What is the ratio of the Health expenditure (as % of GDP) in Mongolia in 2006 to that in 2008?
Ensure brevity in your answer.  0.92. What is the ratio of the Health expenditure (as % of GDP) in European Union in 2006 to that in 2009?
Your answer should be compact. 0.93. What is the ratio of the Health expenditure (as % of GDP) in Moldova in 2006 to that in 2009?
Offer a terse response. 0.92. What is the ratio of the Health expenditure (as % of GDP) of Mongolia in 2006 to that in 2009?
Offer a terse response. 0.88. What is the ratio of the Health expenditure (as % of GDP) of European Union in 2006 to that in 2010?
Your answer should be compact. 0.94. What is the ratio of the Health expenditure (as % of GDP) of Moldova in 2006 to that in 2010?
Provide a succinct answer. 0.93. What is the ratio of the Health expenditure (as % of GDP) in Mongolia in 2006 to that in 2010?
Provide a succinct answer. 0.95. What is the ratio of the Health expenditure (as % of GDP) in European Union in 2007 to that in 2008?
Your answer should be very brief. 0.98. What is the ratio of the Health expenditure (as % of GDP) of Moldova in 2007 to that in 2008?
Your answer should be very brief. 0.99. What is the ratio of the Health expenditure (as % of GDP) of Mongolia in 2007 to that in 2008?
Keep it short and to the point. 0.95. What is the ratio of the Health expenditure (as % of GDP) of European Union in 2007 to that in 2009?
Keep it short and to the point. 0.93. What is the ratio of the Health expenditure (as % of GDP) in Moldova in 2007 to that in 2009?
Your response must be concise. 0.93. What is the ratio of the Health expenditure (as % of GDP) in Mongolia in 2007 to that in 2009?
Keep it short and to the point. 0.9. What is the ratio of the Health expenditure (as % of GDP) of European Union in 2007 to that in 2010?
Your answer should be compact. 0.95. What is the ratio of the Health expenditure (as % of GDP) in Moldova in 2007 to that in 2010?
Offer a very short reply. 0.94. What is the ratio of the Health expenditure (as % of GDP) of Mongolia in 2007 to that in 2010?
Ensure brevity in your answer.  0.97. What is the ratio of the Health expenditure (as % of GDP) of European Union in 2008 to that in 2009?
Provide a succinct answer. 0.95. What is the ratio of the Health expenditure (as % of GDP) in Moldova in 2008 to that in 2009?
Provide a short and direct response. 0.94. What is the ratio of the Health expenditure (as % of GDP) in Mongolia in 2008 to that in 2009?
Your response must be concise. 0.95. What is the ratio of the Health expenditure (as % of GDP) in European Union in 2008 to that in 2010?
Your answer should be compact. 0.97. What is the ratio of the Health expenditure (as % of GDP) in Moldova in 2008 to that in 2010?
Provide a succinct answer. 0.95. What is the ratio of the Health expenditure (as % of GDP) of Mongolia in 2008 to that in 2010?
Keep it short and to the point. 1.02. What is the ratio of the Health expenditure (as % of GDP) of European Union in 2009 to that in 2010?
Keep it short and to the point. 1.02. What is the ratio of the Health expenditure (as % of GDP) in Moldova in 2009 to that in 2010?
Your answer should be very brief. 1.02. What is the ratio of the Health expenditure (as % of GDP) of Mongolia in 2009 to that in 2010?
Offer a very short reply. 1.08. What is the difference between the highest and the second highest Health expenditure (as % of GDP) of European Union?
Offer a very short reply. 0.04. What is the difference between the highest and the second highest Health expenditure (as % of GDP) of Moldova?
Your answer should be compact. 0.1. What is the difference between the highest and the lowest Health expenditure (as % of GDP) in European Union?
Make the answer very short. 0.16. What is the difference between the highest and the lowest Health expenditure (as % of GDP) of Moldova?
Provide a succinct answer. 2.13. What is the difference between the highest and the lowest Health expenditure (as % of GDP) in Mongolia?
Your response must be concise. 1.08. 